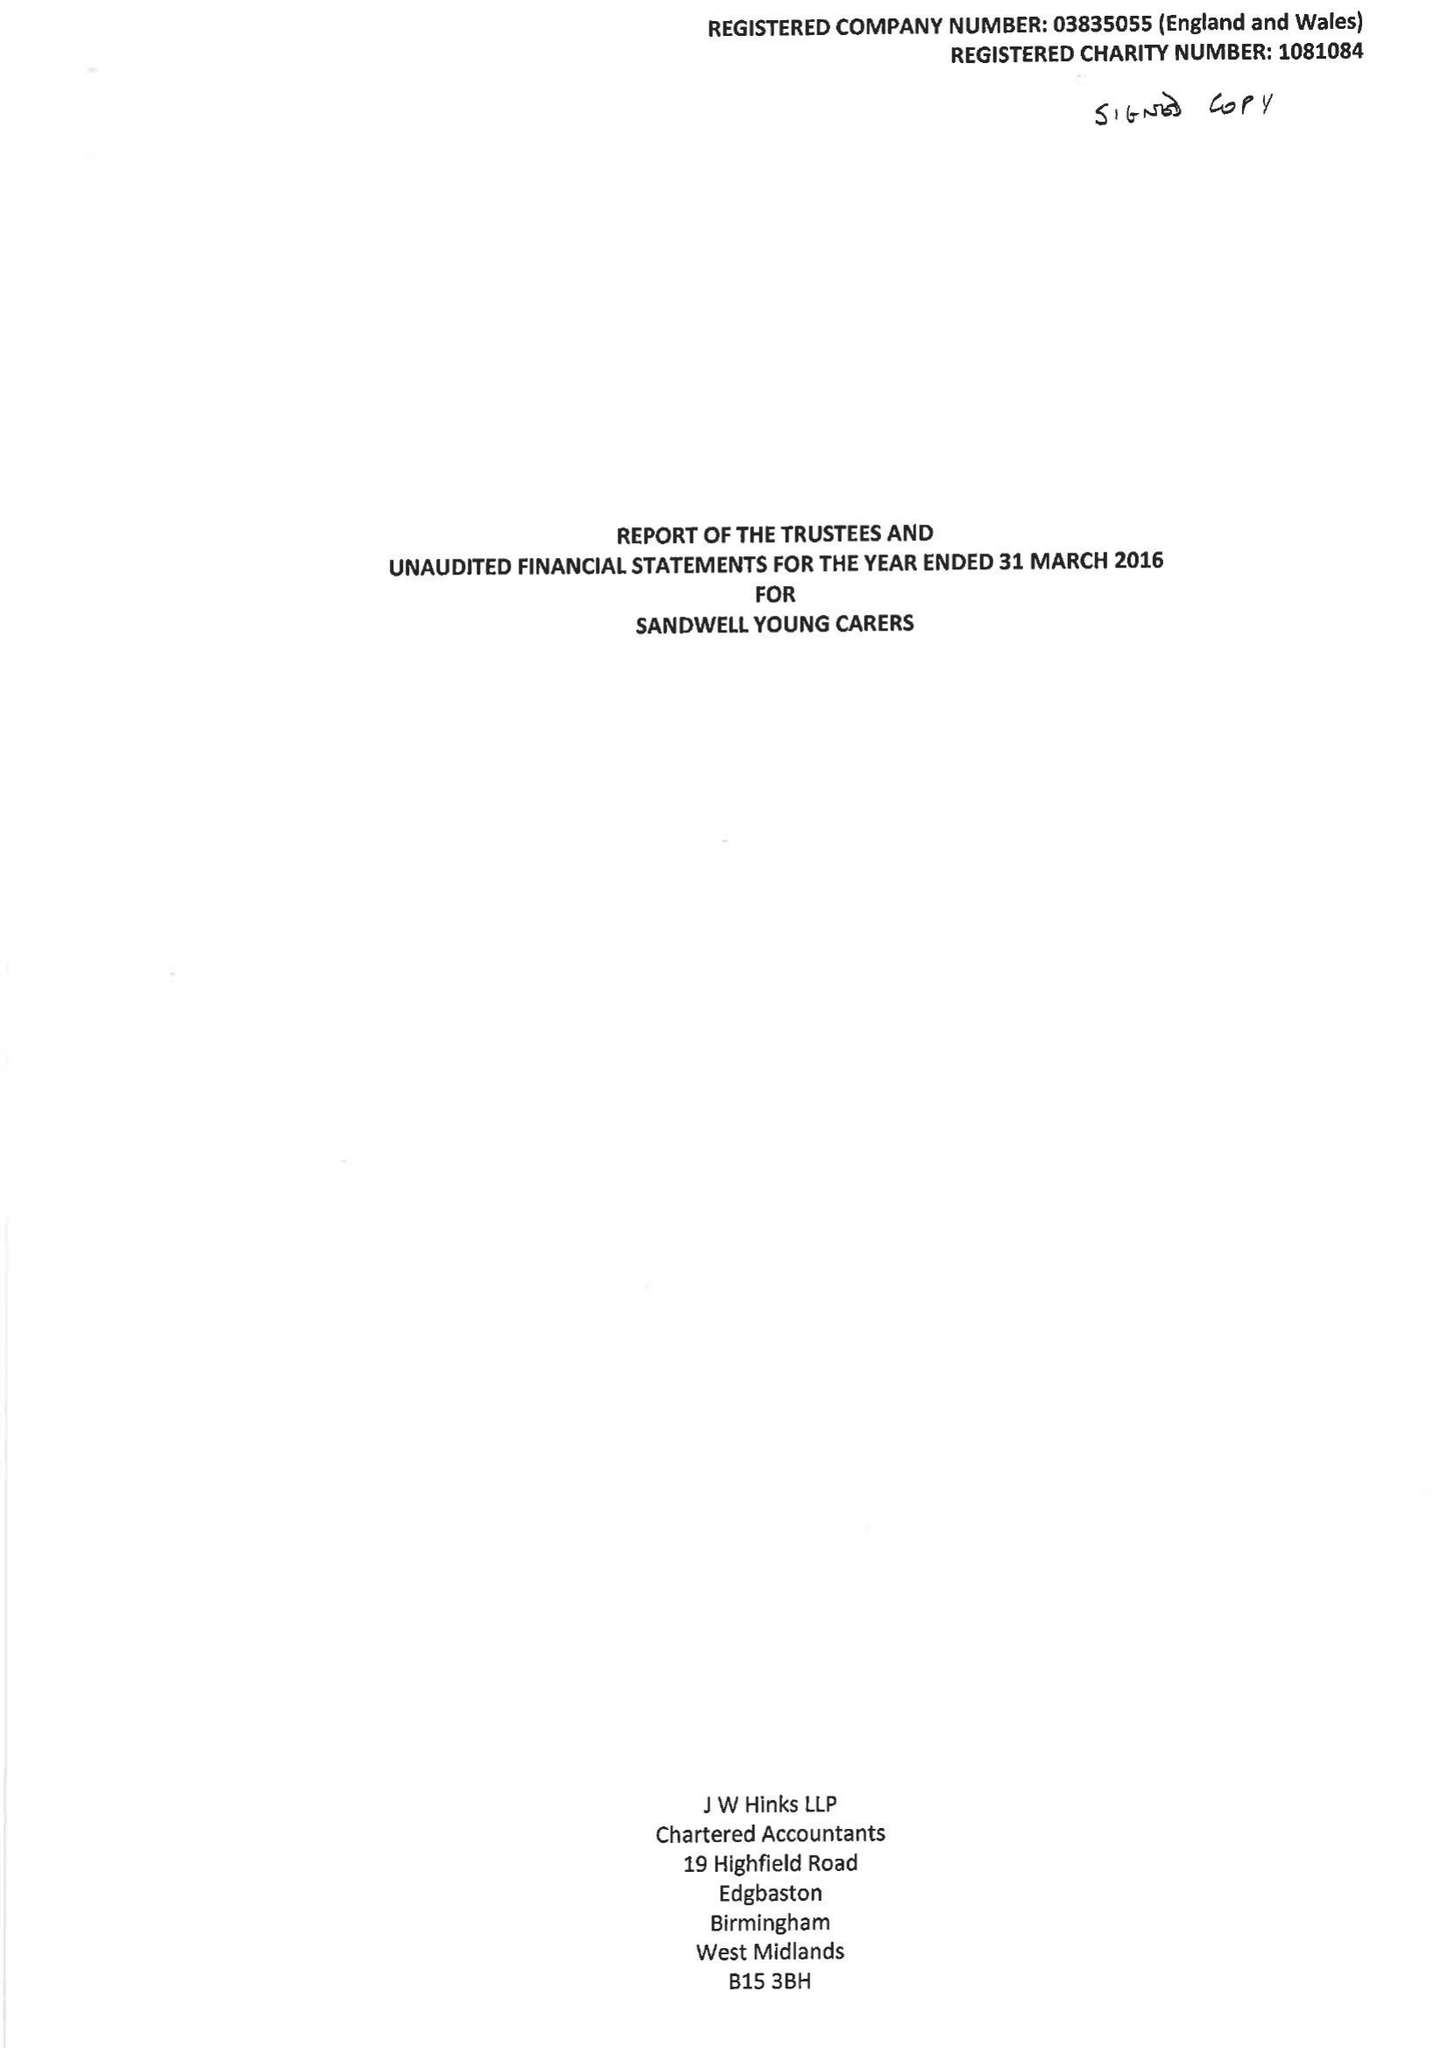What is the value for the report_date?
Answer the question using a single word or phrase. 2016-03-31 